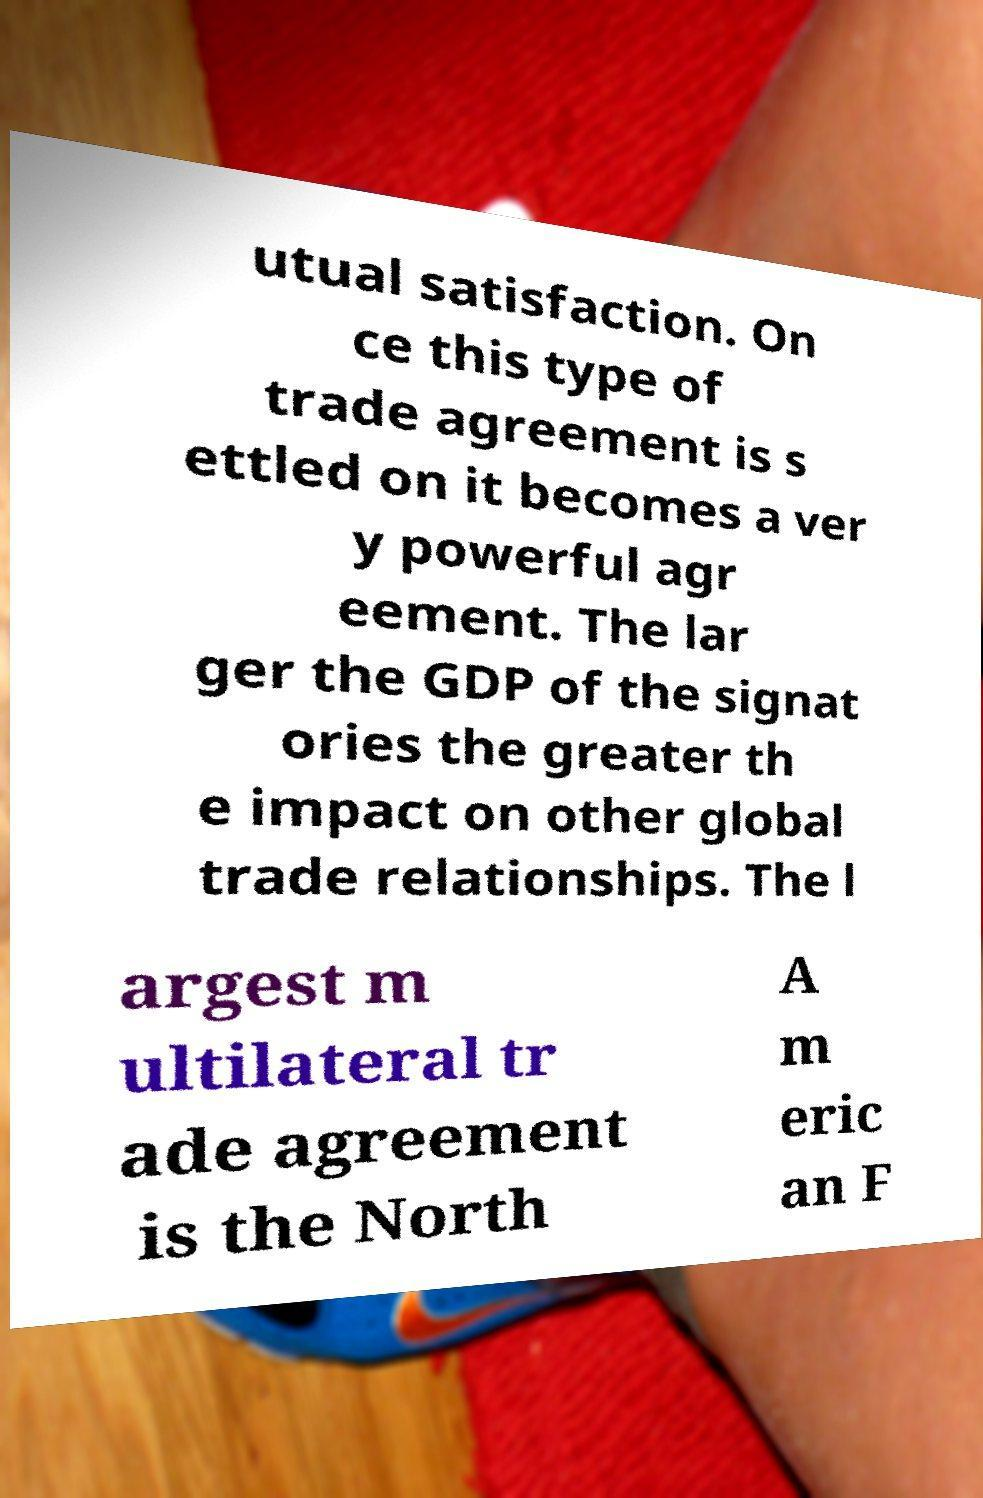Please identify and transcribe the text found in this image. utual satisfaction. On ce this type of trade agreement is s ettled on it becomes a ver y powerful agr eement. The lar ger the GDP of the signat ories the greater th e impact on other global trade relationships. The l argest m ultilateral tr ade agreement is the North A m eric an F 